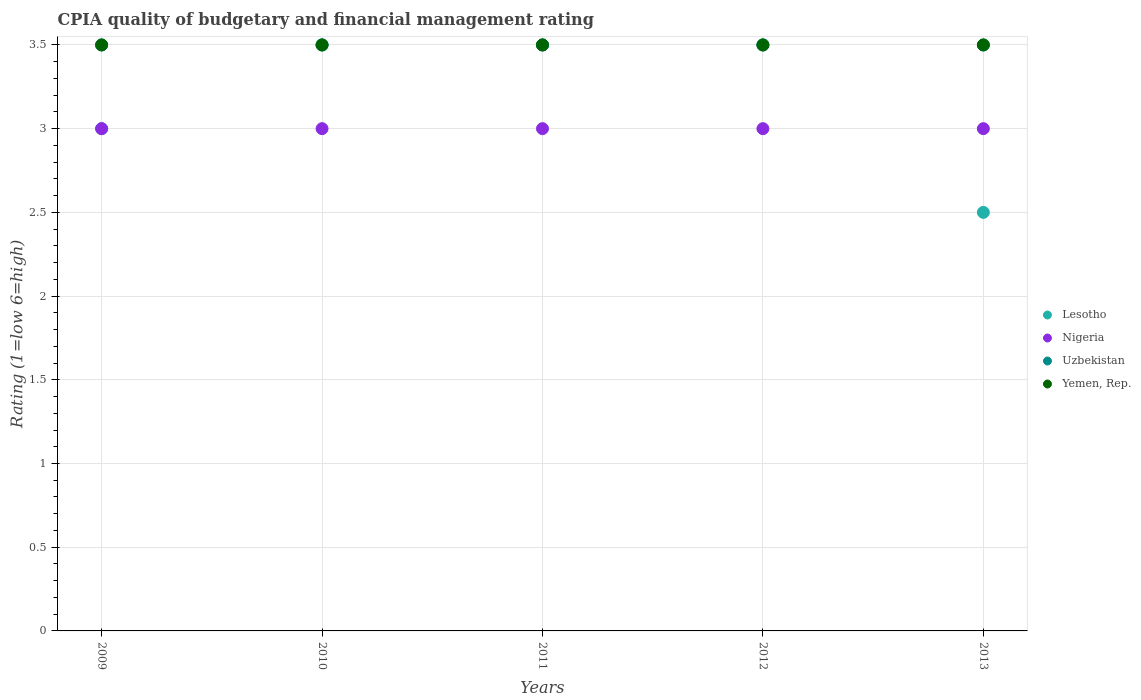How many different coloured dotlines are there?
Provide a succinct answer. 4. Is the number of dotlines equal to the number of legend labels?
Your response must be concise. Yes. What is the CPIA rating in Uzbekistan in 2011?
Give a very brief answer. 3.5. Across all years, what is the maximum CPIA rating in Nigeria?
Keep it short and to the point. 3. What is the total CPIA rating in Lesotho in the graph?
Offer a terse response. 16. What is the ratio of the CPIA rating in Lesotho in 2009 to that in 2012?
Offer a very short reply. 0.86. Is the CPIA rating in Nigeria in 2009 less than that in 2012?
Offer a terse response. No. Is the difference between the CPIA rating in Nigeria in 2010 and 2012 greater than the difference between the CPIA rating in Yemen, Rep. in 2010 and 2012?
Make the answer very short. No. What is the difference between the highest and the second highest CPIA rating in Lesotho?
Provide a short and direct response. 0. In how many years, is the CPIA rating in Lesotho greater than the average CPIA rating in Lesotho taken over all years?
Your answer should be compact. 3. Is the sum of the CPIA rating in Yemen, Rep. in 2012 and 2013 greater than the maximum CPIA rating in Nigeria across all years?
Your answer should be very brief. Yes. Is it the case that in every year, the sum of the CPIA rating in Nigeria and CPIA rating in Yemen, Rep.  is greater than the sum of CPIA rating in Uzbekistan and CPIA rating in Lesotho?
Offer a very short reply. No. Is the CPIA rating in Uzbekistan strictly greater than the CPIA rating in Nigeria over the years?
Your answer should be very brief. Yes. Is the CPIA rating in Yemen, Rep. strictly less than the CPIA rating in Uzbekistan over the years?
Give a very brief answer. No. How many dotlines are there?
Give a very brief answer. 4. Does the graph contain any zero values?
Provide a short and direct response. No. Where does the legend appear in the graph?
Your response must be concise. Center right. How many legend labels are there?
Ensure brevity in your answer.  4. How are the legend labels stacked?
Offer a very short reply. Vertical. What is the title of the graph?
Offer a terse response. CPIA quality of budgetary and financial management rating. What is the Rating (1=low 6=high) of Yemen, Rep. in 2009?
Keep it short and to the point. 3.5. What is the Rating (1=low 6=high) in Nigeria in 2010?
Your answer should be very brief. 3. What is the Rating (1=low 6=high) in Lesotho in 2011?
Provide a succinct answer. 3.5. What is the Rating (1=low 6=high) of Nigeria in 2012?
Your answer should be very brief. 3. What is the Rating (1=low 6=high) of Lesotho in 2013?
Make the answer very short. 2.5. What is the Rating (1=low 6=high) in Uzbekistan in 2013?
Make the answer very short. 3.5. What is the Rating (1=low 6=high) in Yemen, Rep. in 2013?
Offer a very short reply. 3.5. Across all years, what is the minimum Rating (1=low 6=high) in Nigeria?
Keep it short and to the point. 3. Across all years, what is the minimum Rating (1=low 6=high) in Uzbekistan?
Your answer should be very brief. 3.5. Across all years, what is the minimum Rating (1=low 6=high) of Yemen, Rep.?
Ensure brevity in your answer.  3.5. What is the total Rating (1=low 6=high) of Nigeria in the graph?
Keep it short and to the point. 15. What is the total Rating (1=low 6=high) in Uzbekistan in the graph?
Offer a very short reply. 17.5. What is the difference between the Rating (1=low 6=high) of Lesotho in 2009 and that in 2010?
Make the answer very short. -0.5. What is the difference between the Rating (1=low 6=high) in Nigeria in 2009 and that in 2010?
Offer a terse response. 0. What is the difference between the Rating (1=low 6=high) of Uzbekistan in 2009 and that in 2010?
Make the answer very short. 0. What is the difference between the Rating (1=low 6=high) of Nigeria in 2009 and that in 2012?
Ensure brevity in your answer.  0. What is the difference between the Rating (1=low 6=high) of Lesotho in 2009 and that in 2013?
Your answer should be compact. 0.5. What is the difference between the Rating (1=low 6=high) of Nigeria in 2009 and that in 2013?
Your response must be concise. 0. What is the difference between the Rating (1=low 6=high) of Uzbekistan in 2009 and that in 2013?
Provide a short and direct response. 0. What is the difference between the Rating (1=low 6=high) of Yemen, Rep. in 2009 and that in 2013?
Provide a short and direct response. 0. What is the difference between the Rating (1=low 6=high) of Nigeria in 2010 and that in 2011?
Ensure brevity in your answer.  0. What is the difference between the Rating (1=low 6=high) of Uzbekistan in 2010 and that in 2011?
Your answer should be very brief. 0. What is the difference between the Rating (1=low 6=high) of Lesotho in 2010 and that in 2012?
Offer a terse response. 0. What is the difference between the Rating (1=low 6=high) of Nigeria in 2010 and that in 2012?
Make the answer very short. 0. What is the difference between the Rating (1=low 6=high) of Yemen, Rep. in 2010 and that in 2012?
Offer a very short reply. 0. What is the difference between the Rating (1=low 6=high) in Yemen, Rep. in 2010 and that in 2013?
Your response must be concise. 0. What is the difference between the Rating (1=low 6=high) in Nigeria in 2011 and that in 2012?
Ensure brevity in your answer.  0. What is the difference between the Rating (1=low 6=high) of Yemen, Rep. in 2011 and that in 2012?
Ensure brevity in your answer.  0. What is the difference between the Rating (1=low 6=high) of Nigeria in 2012 and that in 2013?
Offer a very short reply. 0. What is the difference between the Rating (1=low 6=high) of Uzbekistan in 2012 and that in 2013?
Your answer should be very brief. 0. What is the difference between the Rating (1=low 6=high) in Lesotho in 2009 and the Rating (1=low 6=high) in Nigeria in 2010?
Make the answer very short. 0. What is the difference between the Rating (1=low 6=high) in Lesotho in 2009 and the Rating (1=low 6=high) in Uzbekistan in 2010?
Give a very brief answer. -0.5. What is the difference between the Rating (1=low 6=high) of Lesotho in 2009 and the Rating (1=low 6=high) of Yemen, Rep. in 2010?
Offer a terse response. -0.5. What is the difference between the Rating (1=low 6=high) in Nigeria in 2009 and the Rating (1=low 6=high) in Uzbekistan in 2010?
Your response must be concise. -0.5. What is the difference between the Rating (1=low 6=high) of Lesotho in 2009 and the Rating (1=low 6=high) of Uzbekistan in 2011?
Your response must be concise. -0.5. What is the difference between the Rating (1=low 6=high) in Lesotho in 2009 and the Rating (1=low 6=high) in Yemen, Rep. in 2011?
Offer a very short reply. -0.5. What is the difference between the Rating (1=low 6=high) in Nigeria in 2009 and the Rating (1=low 6=high) in Yemen, Rep. in 2011?
Ensure brevity in your answer.  -0.5. What is the difference between the Rating (1=low 6=high) of Lesotho in 2009 and the Rating (1=low 6=high) of Yemen, Rep. in 2012?
Your answer should be very brief. -0.5. What is the difference between the Rating (1=low 6=high) of Nigeria in 2009 and the Rating (1=low 6=high) of Yemen, Rep. in 2012?
Give a very brief answer. -0.5. What is the difference between the Rating (1=low 6=high) in Uzbekistan in 2009 and the Rating (1=low 6=high) in Yemen, Rep. in 2012?
Your answer should be very brief. 0. What is the difference between the Rating (1=low 6=high) in Lesotho in 2009 and the Rating (1=low 6=high) in Nigeria in 2013?
Your answer should be very brief. 0. What is the difference between the Rating (1=low 6=high) in Lesotho in 2009 and the Rating (1=low 6=high) in Yemen, Rep. in 2013?
Your answer should be compact. -0.5. What is the difference between the Rating (1=low 6=high) of Nigeria in 2009 and the Rating (1=low 6=high) of Uzbekistan in 2013?
Your response must be concise. -0.5. What is the difference between the Rating (1=low 6=high) of Lesotho in 2010 and the Rating (1=low 6=high) of Nigeria in 2011?
Offer a very short reply. 0.5. What is the difference between the Rating (1=low 6=high) of Lesotho in 2010 and the Rating (1=low 6=high) of Uzbekistan in 2011?
Give a very brief answer. 0. What is the difference between the Rating (1=low 6=high) in Lesotho in 2010 and the Rating (1=low 6=high) in Yemen, Rep. in 2011?
Give a very brief answer. 0. What is the difference between the Rating (1=low 6=high) of Nigeria in 2010 and the Rating (1=low 6=high) of Uzbekistan in 2011?
Provide a succinct answer. -0.5. What is the difference between the Rating (1=low 6=high) of Nigeria in 2010 and the Rating (1=low 6=high) of Yemen, Rep. in 2011?
Ensure brevity in your answer.  -0.5. What is the difference between the Rating (1=low 6=high) of Lesotho in 2010 and the Rating (1=low 6=high) of Yemen, Rep. in 2012?
Make the answer very short. 0. What is the difference between the Rating (1=low 6=high) in Uzbekistan in 2010 and the Rating (1=low 6=high) in Yemen, Rep. in 2012?
Make the answer very short. 0. What is the difference between the Rating (1=low 6=high) in Lesotho in 2010 and the Rating (1=low 6=high) in Uzbekistan in 2013?
Make the answer very short. 0. What is the difference between the Rating (1=low 6=high) of Lesotho in 2010 and the Rating (1=low 6=high) of Yemen, Rep. in 2013?
Provide a short and direct response. 0. What is the difference between the Rating (1=low 6=high) in Nigeria in 2010 and the Rating (1=low 6=high) in Uzbekistan in 2013?
Make the answer very short. -0.5. What is the difference between the Rating (1=low 6=high) in Lesotho in 2011 and the Rating (1=low 6=high) in Nigeria in 2012?
Make the answer very short. 0.5. What is the difference between the Rating (1=low 6=high) of Lesotho in 2011 and the Rating (1=low 6=high) of Uzbekistan in 2012?
Offer a terse response. 0. What is the difference between the Rating (1=low 6=high) in Lesotho in 2011 and the Rating (1=low 6=high) in Yemen, Rep. in 2012?
Make the answer very short. 0. What is the difference between the Rating (1=low 6=high) in Lesotho in 2011 and the Rating (1=low 6=high) in Nigeria in 2013?
Your answer should be compact. 0.5. What is the difference between the Rating (1=low 6=high) of Lesotho in 2011 and the Rating (1=low 6=high) of Yemen, Rep. in 2013?
Offer a terse response. 0. What is the difference between the Rating (1=low 6=high) of Nigeria in 2011 and the Rating (1=low 6=high) of Uzbekistan in 2013?
Your answer should be compact. -0.5. What is the difference between the Rating (1=low 6=high) of Nigeria in 2011 and the Rating (1=low 6=high) of Yemen, Rep. in 2013?
Ensure brevity in your answer.  -0.5. What is the difference between the Rating (1=low 6=high) in Uzbekistan in 2011 and the Rating (1=low 6=high) in Yemen, Rep. in 2013?
Your answer should be compact. 0. What is the difference between the Rating (1=low 6=high) in Lesotho in 2012 and the Rating (1=low 6=high) in Yemen, Rep. in 2013?
Offer a very short reply. 0. What is the average Rating (1=low 6=high) of Lesotho per year?
Give a very brief answer. 3.2. In the year 2009, what is the difference between the Rating (1=low 6=high) in Lesotho and Rating (1=low 6=high) in Uzbekistan?
Offer a terse response. -0.5. In the year 2009, what is the difference between the Rating (1=low 6=high) in Lesotho and Rating (1=low 6=high) in Yemen, Rep.?
Keep it short and to the point. -0.5. In the year 2009, what is the difference between the Rating (1=low 6=high) of Nigeria and Rating (1=low 6=high) of Yemen, Rep.?
Provide a short and direct response. -0.5. In the year 2010, what is the difference between the Rating (1=low 6=high) in Lesotho and Rating (1=low 6=high) in Nigeria?
Offer a very short reply. 0.5. In the year 2010, what is the difference between the Rating (1=low 6=high) in Nigeria and Rating (1=low 6=high) in Uzbekistan?
Offer a very short reply. -0.5. In the year 2011, what is the difference between the Rating (1=low 6=high) of Lesotho and Rating (1=low 6=high) of Uzbekistan?
Provide a short and direct response. 0. In the year 2011, what is the difference between the Rating (1=low 6=high) of Lesotho and Rating (1=low 6=high) of Yemen, Rep.?
Your answer should be very brief. 0. In the year 2011, what is the difference between the Rating (1=low 6=high) in Uzbekistan and Rating (1=low 6=high) in Yemen, Rep.?
Provide a short and direct response. 0. In the year 2012, what is the difference between the Rating (1=low 6=high) of Lesotho and Rating (1=low 6=high) of Yemen, Rep.?
Your answer should be very brief. 0. In the year 2012, what is the difference between the Rating (1=low 6=high) in Nigeria and Rating (1=low 6=high) in Yemen, Rep.?
Your answer should be compact. -0.5. In the year 2013, what is the difference between the Rating (1=low 6=high) of Nigeria and Rating (1=low 6=high) of Yemen, Rep.?
Offer a terse response. -0.5. What is the ratio of the Rating (1=low 6=high) in Nigeria in 2009 to that in 2010?
Offer a very short reply. 1. What is the ratio of the Rating (1=low 6=high) of Uzbekistan in 2009 to that in 2010?
Your response must be concise. 1. What is the ratio of the Rating (1=low 6=high) of Yemen, Rep. in 2009 to that in 2010?
Keep it short and to the point. 1. What is the ratio of the Rating (1=low 6=high) in Nigeria in 2009 to that in 2011?
Make the answer very short. 1. What is the ratio of the Rating (1=low 6=high) of Yemen, Rep. in 2009 to that in 2011?
Offer a terse response. 1. What is the ratio of the Rating (1=low 6=high) in Nigeria in 2009 to that in 2012?
Ensure brevity in your answer.  1. What is the ratio of the Rating (1=low 6=high) of Uzbekistan in 2009 to that in 2012?
Your response must be concise. 1. What is the ratio of the Rating (1=low 6=high) of Lesotho in 2009 to that in 2013?
Make the answer very short. 1.2. What is the ratio of the Rating (1=low 6=high) of Nigeria in 2009 to that in 2013?
Offer a terse response. 1. What is the ratio of the Rating (1=low 6=high) in Uzbekistan in 2009 to that in 2013?
Your answer should be very brief. 1. What is the ratio of the Rating (1=low 6=high) of Nigeria in 2010 to that in 2012?
Offer a very short reply. 1. What is the ratio of the Rating (1=low 6=high) in Nigeria in 2010 to that in 2013?
Your response must be concise. 1. What is the ratio of the Rating (1=low 6=high) of Uzbekistan in 2010 to that in 2013?
Make the answer very short. 1. What is the ratio of the Rating (1=low 6=high) of Yemen, Rep. in 2010 to that in 2013?
Your answer should be compact. 1. What is the ratio of the Rating (1=low 6=high) of Lesotho in 2011 to that in 2012?
Provide a short and direct response. 1. What is the ratio of the Rating (1=low 6=high) of Uzbekistan in 2011 to that in 2012?
Offer a terse response. 1. What is the ratio of the Rating (1=low 6=high) of Yemen, Rep. in 2011 to that in 2012?
Provide a short and direct response. 1. What is the ratio of the Rating (1=low 6=high) of Nigeria in 2011 to that in 2013?
Provide a short and direct response. 1. What is the ratio of the Rating (1=low 6=high) in Yemen, Rep. in 2011 to that in 2013?
Keep it short and to the point. 1. What is the ratio of the Rating (1=low 6=high) of Lesotho in 2012 to that in 2013?
Your answer should be compact. 1.4. What is the ratio of the Rating (1=low 6=high) in Nigeria in 2012 to that in 2013?
Provide a short and direct response. 1. What is the ratio of the Rating (1=low 6=high) of Uzbekistan in 2012 to that in 2013?
Offer a terse response. 1. What is the difference between the highest and the second highest Rating (1=low 6=high) in Lesotho?
Give a very brief answer. 0. What is the difference between the highest and the second highest Rating (1=low 6=high) of Nigeria?
Your answer should be compact. 0. What is the difference between the highest and the second highest Rating (1=low 6=high) of Yemen, Rep.?
Ensure brevity in your answer.  0. What is the difference between the highest and the lowest Rating (1=low 6=high) in Lesotho?
Your answer should be compact. 1. What is the difference between the highest and the lowest Rating (1=low 6=high) of Nigeria?
Provide a succinct answer. 0. 